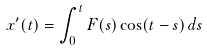Convert formula to latex. <formula><loc_0><loc_0><loc_500><loc_500>x ^ { \prime } ( t ) = \int _ { 0 } ^ { t } F ( s ) \cos ( t - s ) \, d s</formula> 